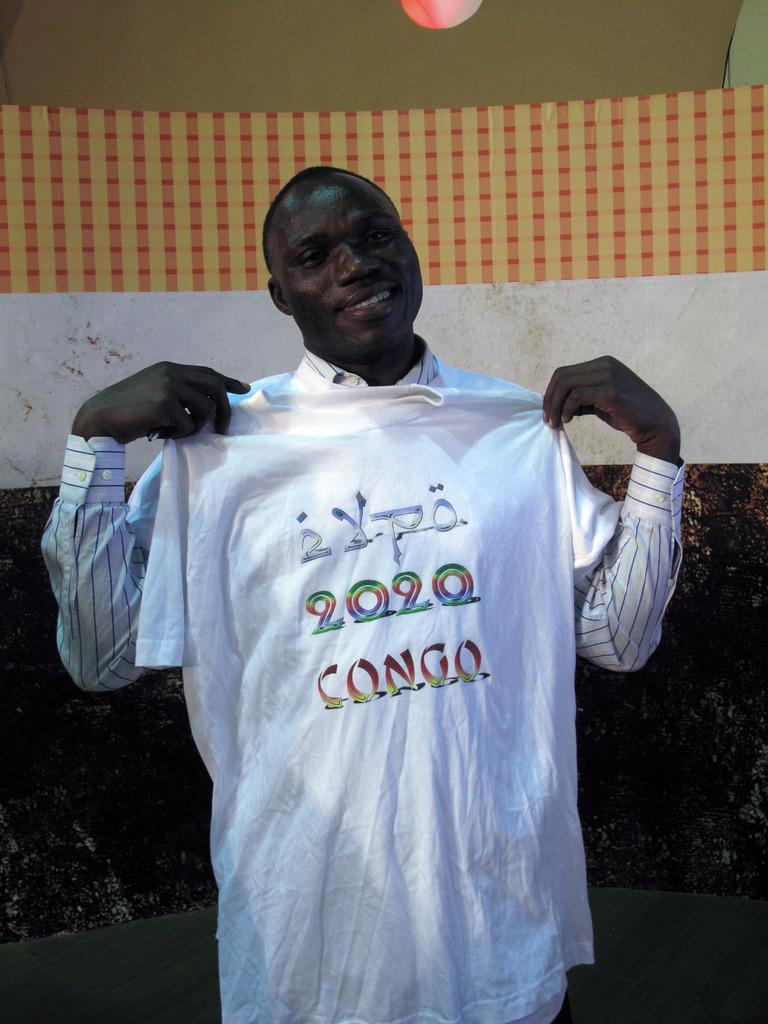<image>
Give a short and clear explanation of the subsequent image. A black man smiles while holding up a t-shirt that says 2020 Congo. 